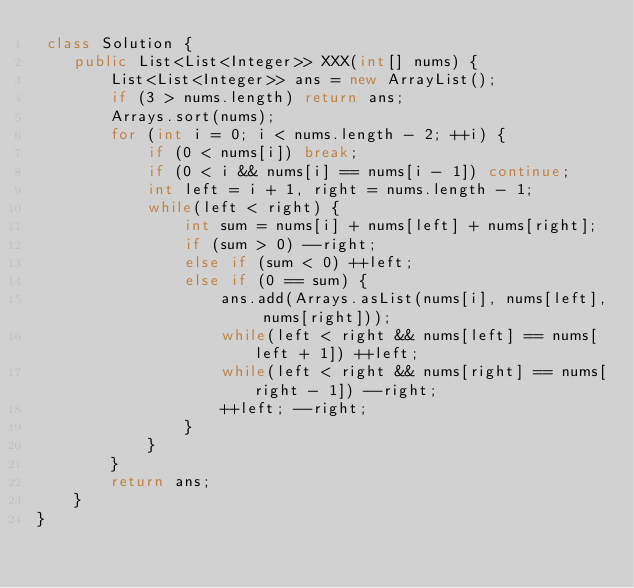<code> <loc_0><loc_0><loc_500><loc_500><_Java_> class Solution {
    public List<List<Integer>> XXX(int[] nums) {
        List<List<Integer>> ans = new ArrayList();
        if (3 > nums.length) return ans;
        Arrays.sort(nums);
        for (int i = 0; i < nums.length - 2; ++i) {
            if (0 < nums[i]) break;
            if (0 < i && nums[i] == nums[i - 1]) continue;
            int left = i + 1, right = nums.length - 1;
            while(left < right) {
                int sum = nums[i] + nums[left] + nums[right];
                if (sum > 0) --right;
                else if (sum < 0) ++left;
                else if (0 == sum) {
                    ans.add(Arrays.asList(nums[i], nums[left], nums[right]));
                    while(left < right && nums[left] == nums[left + 1]) ++left;
                    while(left < right && nums[right] == nums[right - 1]) --right;
                    ++left; --right;
                }
            }
        }
        return ans;
    }
}

</code> 